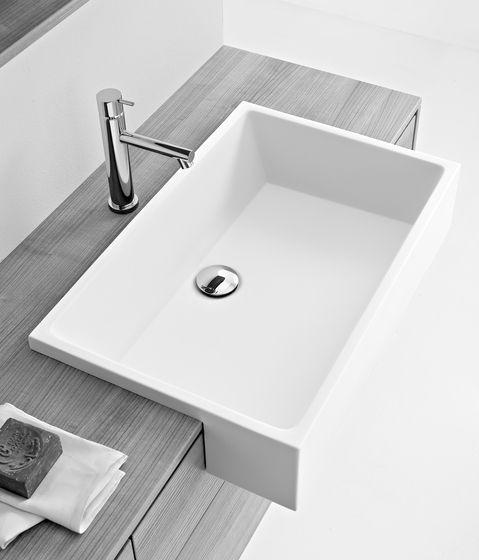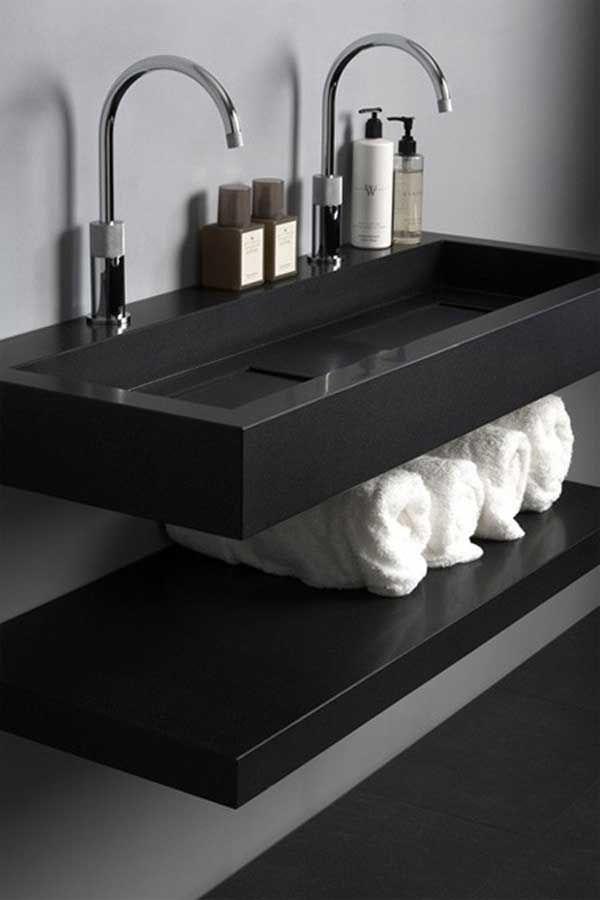The first image is the image on the left, the second image is the image on the right. Analyze the images presented: Is the assertion "The right image shows an oblong bowl-shaped sink." valid? Answer yes or no. No. 